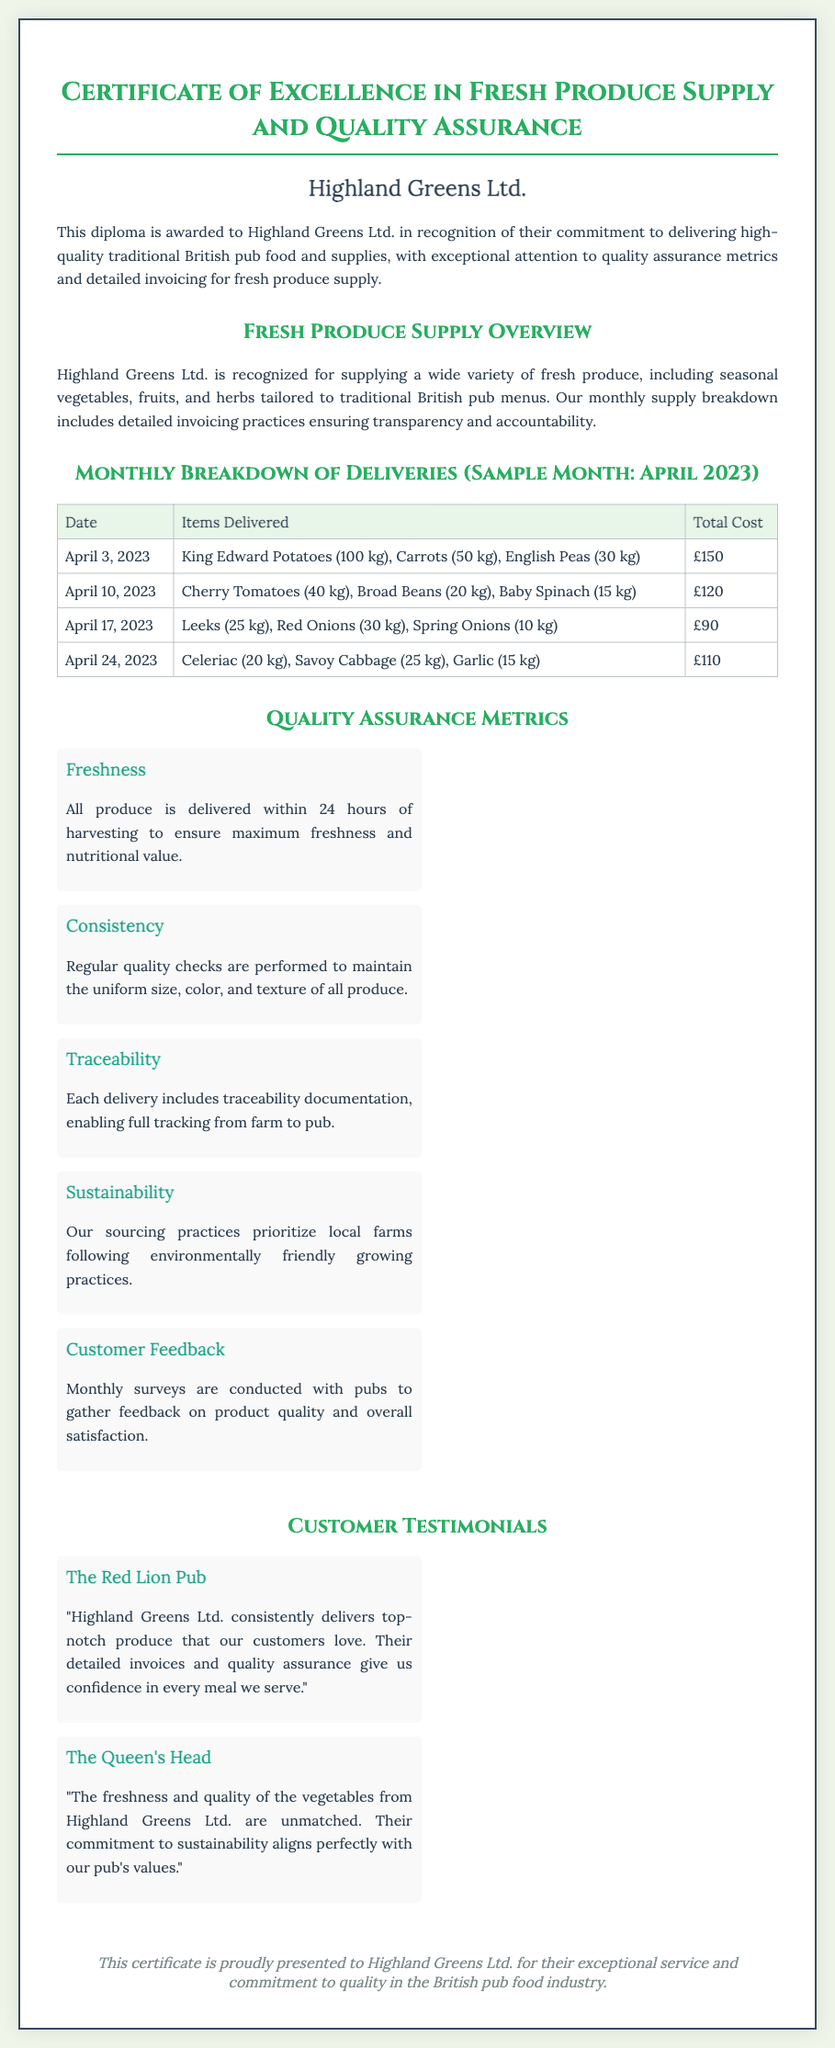What is the title of the document? The title of the document is presented at the top and describes the purpose of the diploma.
Answer: Certificate of Excellence in Fresh Produce Supply and Quality Assurance Who is the vendor recognized in the diploma? The vendor recognized in the diploma is stated prominently within the document.
Answer: Highland Greens Ltd What is the date of the first delivery in April 2023? The date of the first delivery is mentioned in the monthly breakdown table.
Answer: April 3, 2023 How much was the total cost for the delivery on April 10, 2023? The total cost for that delivery is specified in the monthly breakdown table.
Answer: £120 What is the main focus of Highland Greens Ltd. regarding their produce? The primary focus regarding their produce is clearly stated in the quality assurance section.
Answer: Freshness What type of feedback does Highland Greens Ltd. gather from customers? The type of feedback mentioned is related to the customer interaction practices documented in the metrics section.
Answer: Monthly surveys Which pub spoke positively about Highland Greens Ltd.'s produce? A testimonial in the document mentions a specific pub that endorses the vendor's services.
Answer: The Red Lion Pub How many items delivered were recorded on April 24, 2023? The number of items can be identified from the details provided for that delivery in the table.
Answer: 3 items What aspect of the business aligns with sustainability? The document attributes sustainability to a specific practice related to sourcing.
Answer: Environmentally friendly growing practices 